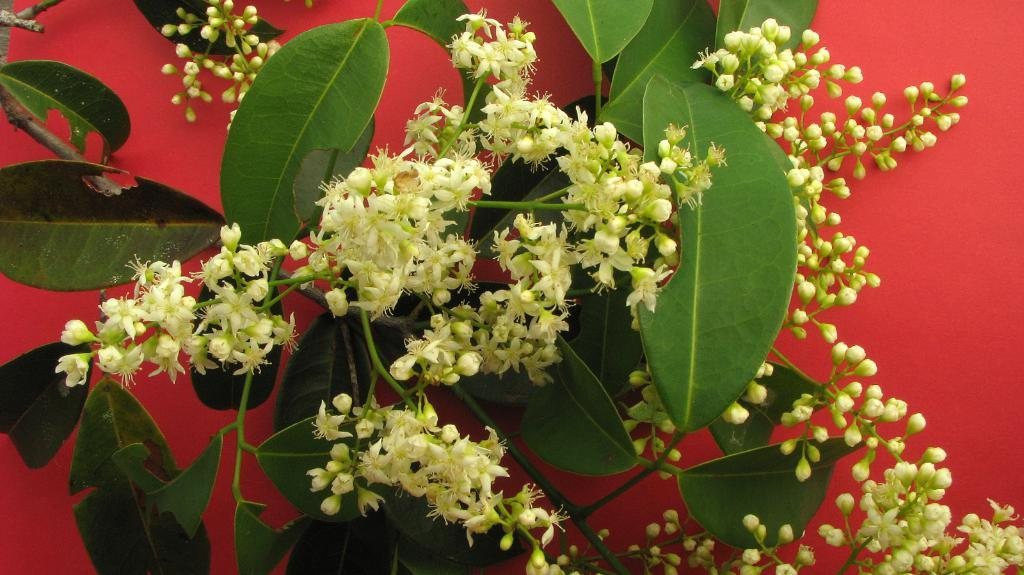What type of plants can be seen in the picture? There are flower plants in the picture. What is the color of the surface on which the flower plants are placed? The flower plants are on a red surface. What is the color of the flowers? The flowers are white in color. What type of card can be seen in the picture? There is no card present in the picture; it features flower plants on a red surface with white flowers. 